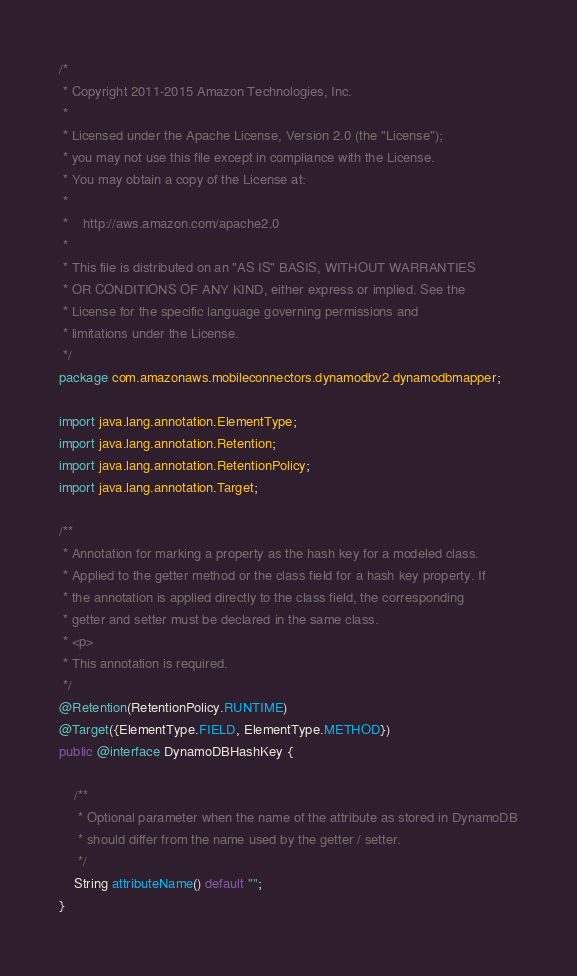<code> <loc_0><loc_0><loc_500><loc_500><_Java_>/*
 * Copyright 2011-2015 Amazon Technologies, Inc.
 *
 * Licensed under the Apache License, Version 2.0 (the "License");
 * you may not use this file except in compliance with the License.
 * You may obtain a copy of the License at:
 *
 *    http://aws.amazon.com/apache2.0
 *
 * This file is distributed on an "AS IS" BASIS, WITHOUT WARRANTIES
 * OR CONDITIONS OF ANY KIND, either express or implied. See the
 * License for the specific language governing permissions and
 * limitations under the License.
 */
package com.amazonaws.mobileconnectors.dynamodbv2.dynamodbmapper;

import java.lang.annotation.ElementType;
import java.lang.annotation.Retention;
import java.lang.annotation.RetentionPolicy;
import java.lang.annotation.Target;

/**
 * Annotation for marking a property as the hash key for a modeled class.
 * Applied to the getter method or the class field for a hash key property. If
 * the annotation is applied directly to the class field, the corresponding
 * getter and setter must be declared in the same class.
 * <p>
 * This annotation is required.
 */
@Retention(RetentionPolicy.RUNTIME)
@Target({ElementType.FIELD, ElementType.METHOD})
public @interface DynamoDBHashKey {

    /**
     * Optional parameter when the name of the attribute as stored in DynamoDB
     * should differ from the name used by the getter / setter.
     */
    String attributeName() default "";
}</code> 